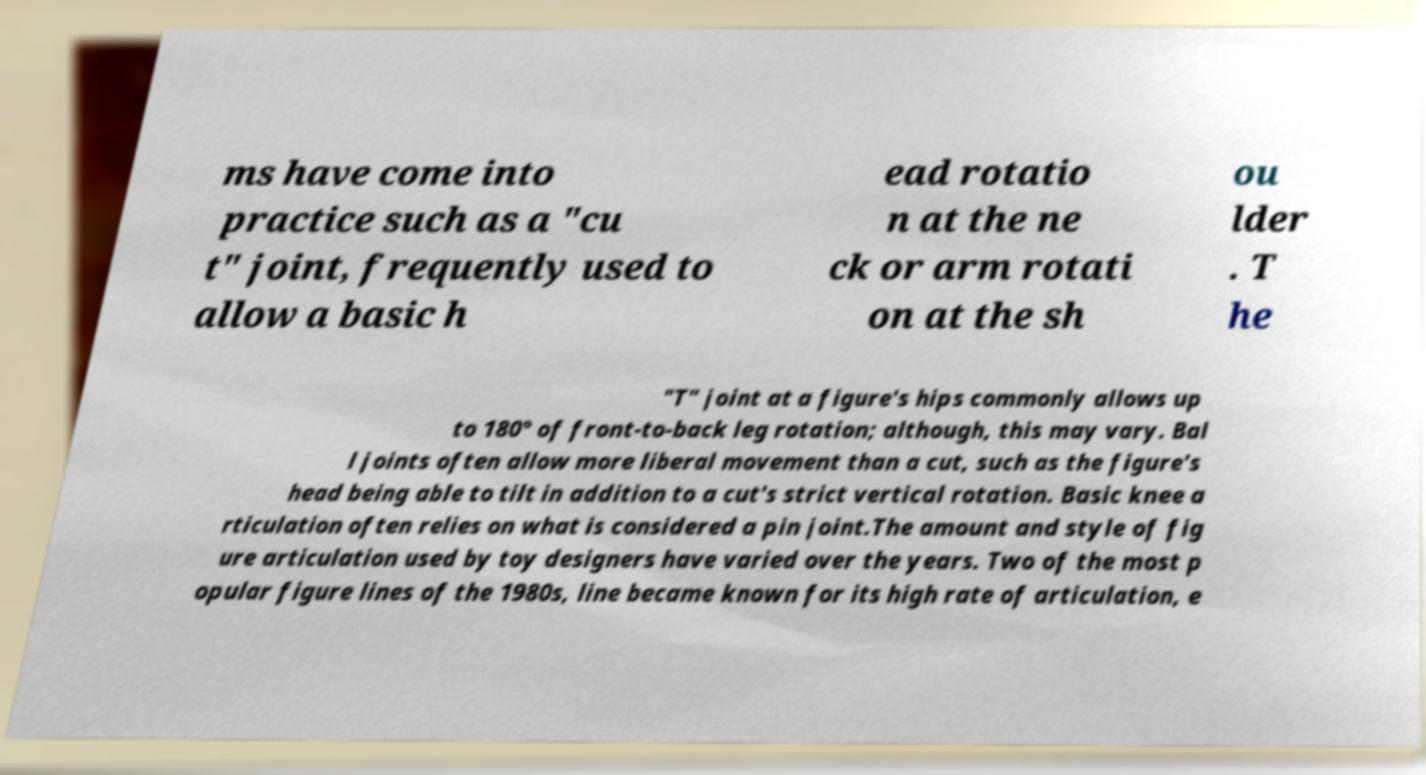Please read and relay the text visible in this image. What does it say? ms have come into practice such as a "cu t" joint, frequently used to allow a basic h ead rotatio n at the ne ck or arm rotati on at the sh ou lder . T he "T" joint at a figure's hips commonly allows up to 180° of front-to-back leg rotation; although, this may vary. Bal l joints often allow more liberal movement than a cut, such as the figure's head being able to tilt in addition to a cut's strict vertical rotation. Basic knee a rticulation often relies on what is considered a pin joint.The amount and style of fig ure articulation used by toy designers have varied over the years. Two of the most p opular figure lines of the 1980s, line became known for its high rate of articulation, e 